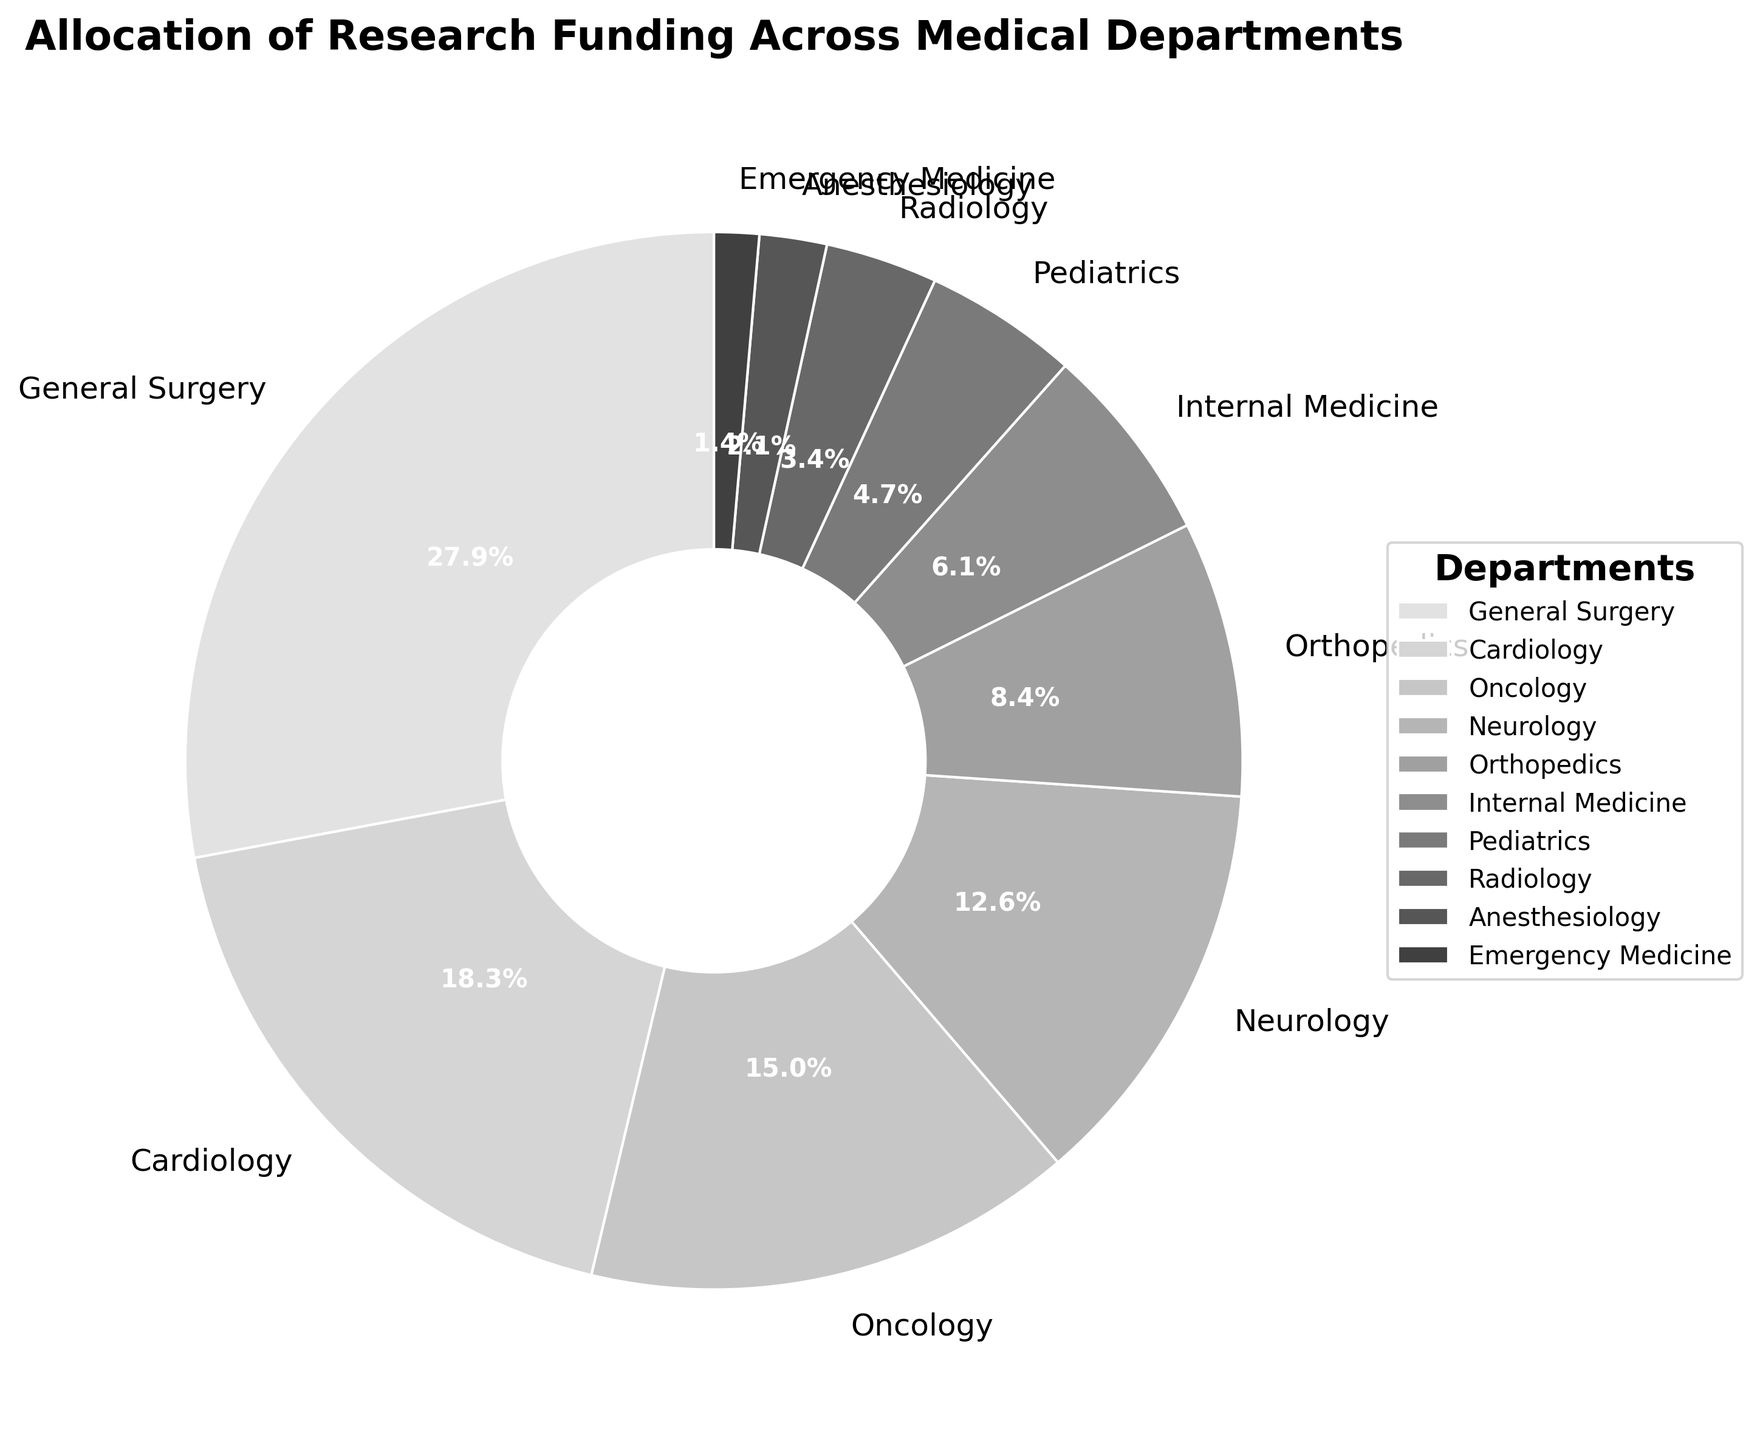Which department has the highest allocation of research funding? The pie chart shows that the General Surgery department has the largest segment, which corresponds to the highest funding percentage.
Answer: General Surgery What is the total funding percentage allocated to Oncology and Neurology combined? The funding percentage for Oncology is 15.3% and for Neurology is 12.9%. The combined funding is calculated as 15.3 + 12.9 = 28.2%.
Answer: 28.2% Which department has a higher funding allocation: Orthopedics or Pediatrics? The pie chart shows that Orthopedics has an allocation of 8.6%, while Pediatrics has 4.8%. Therefore, Orthopedics has a higher allocation.
Answer: Orthopedics What is the difference in funding percentage between Cardiology and Emergency Medicine? The funding percentage for Cardiology is 18.7% and for Emergency Medicine is 1.4%. The difference is calculated as 18.7 - 1.4 = 17.3%.
Answer: 17.3% Arrange the departments in ascending order of their funding allocation percentages. By analyzing the pie chart, we can order the departments from smallest to largest allocation: Emergency Medicine (1.4%), Anesthesiology (2.1%), Radiology (3.5%), Pediatrics (4.8%), Internal Medicine (6.2%), Orthopedics (8.6%), Neurology (12.9%), Oncology (15.3%), Cardiology (18.7%), General Surgery (28.5%).
Answer: Emergency Medicine, Anesthesiology, Radiology, Pediatrics, Internal Medicine, Orthopedics, Neurology, Oncology, Cardiology, General Surgery What percentage of the total funding is allocated to departments other than General Surgery and Cardiology? General Surgery and Cardiology together have 28.5% + 18.7% = 47.2%. The remaining percentage is 100% - 47.2% = 52.8%.
Answer: 52.8% What's the average funding percentage for the departments with less than 10% allocation? Departments with less than 10% allocation are Orthopedics (8.6%), Internal Medicine (6.2%), Pediatrics (4.8%), Radiology (3.5%), Anesthesiology (2.1%), Emergency Medicine (1.4%). Sum = 8.6 + 6.2 + 4.8 + 3.5 + 2.1 + 1.4 = 26.6. Number of departments = 6. Average = 26.6 / 6 = 4.43%.
Answer: 4.43% What is the total funding percentage for departments related to surgery (General Surgery and Orthopedics)? The funding percentage for General Surgery is 28.5% and for Orthopedics is 8.6%, giving a total of 28.5 + 8.6 = 37.1%.
Answer: 37.1% Which two departments have the closest funding allocation percentages? By examining the pie chart, Internal Medicine (6.2%) and Pediatrics (4.8%) have a close difference of 1.4%.
Answer: Internal Medicine and Pediatrics 